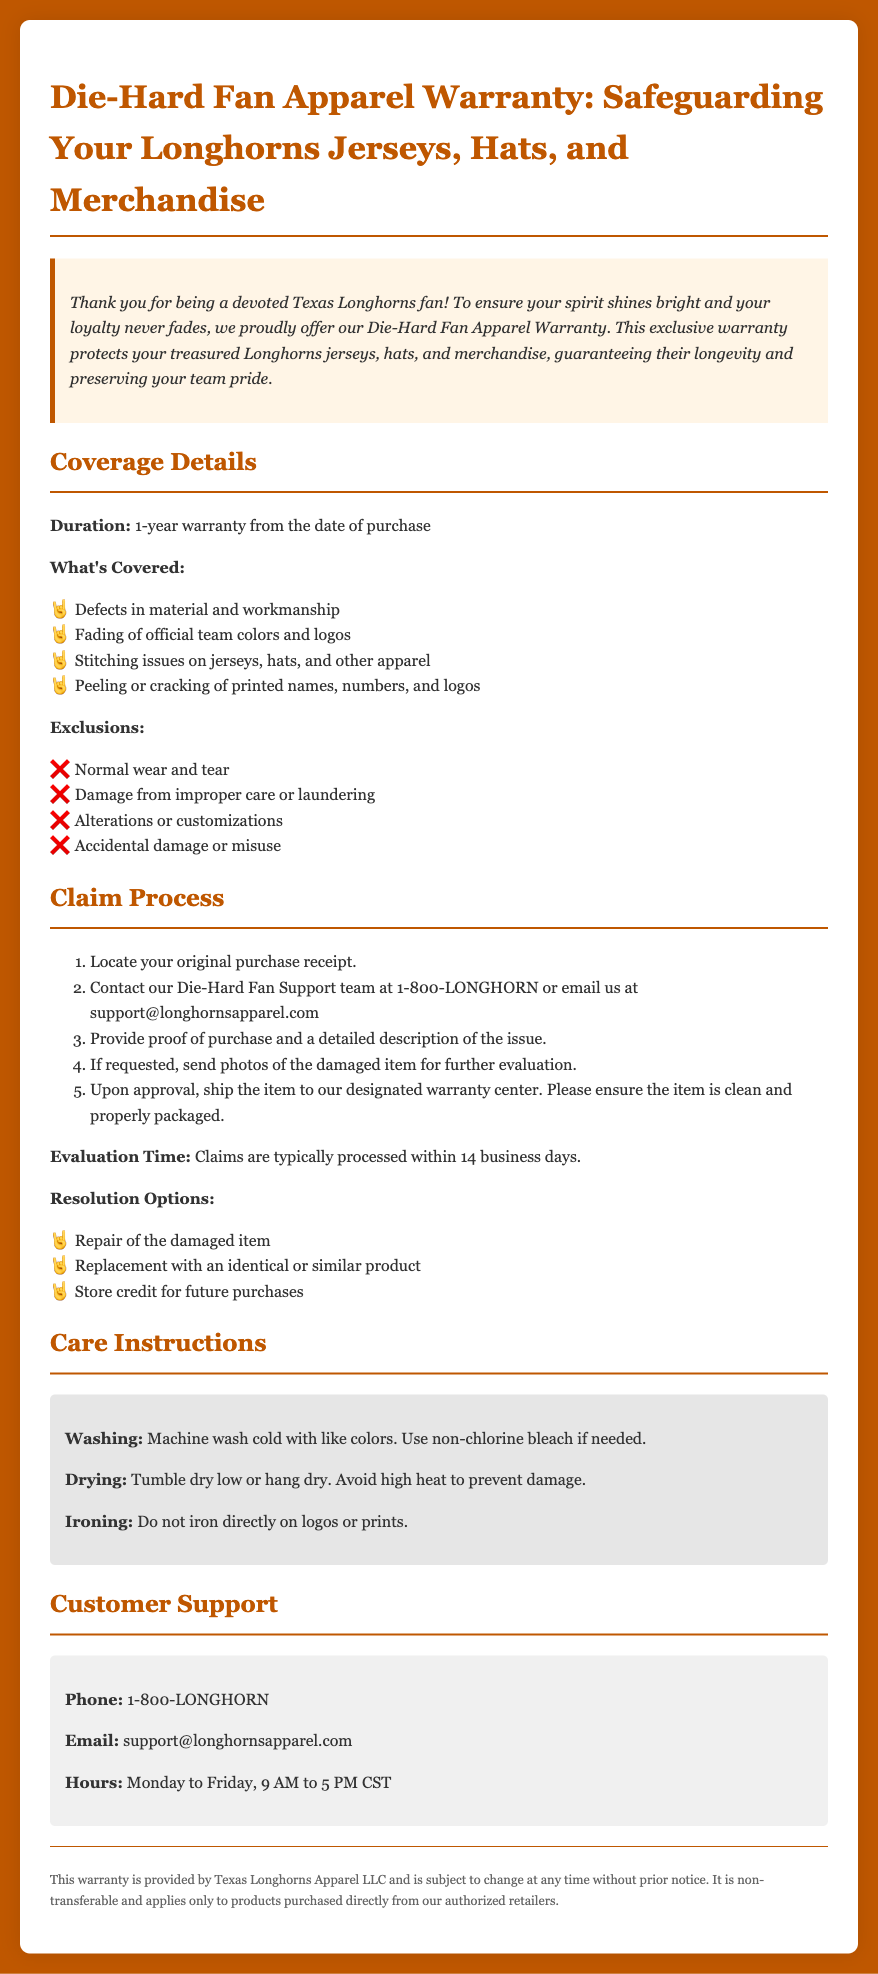What is the warranty duration? The warranty lasts for 1-year from the date of purchase according to the document.
Answer: 1-year What is covered under the warranty? The warranty covers defects in material and workmanship, among other things as listed.
Answer: Defects in material and workmanship What should you avoid to ensure coverage? The exclusions list what should be avoided; for instance, normal wear and tear is one of the exclusions.
Answer: Normal wear and tear What is the customer support phone number? The document lists the customer support phone number as 1-800-LONGHORN.
Answer: 1-800-LONGHORN What documentation is needed to file a claim? You need to provide the original purchase receipt to file a claim, as mentioned in the claim process.
Answer: Original purchase receipt How quickly are claims processed? The document states that claims are typically processed within 14 business days.
Answer: 14 business days What options are available for resolution? The warranty provides multiple resolution options, including repair or replacement of the item.
Answer: Repair of the damaged item What is the care instruction for washing? The document specifically instructs to machine wash cold with like colors.
Answer: Machine wash cold with like colors What are the warranty exclusions? Exclusions include damage from improper care or laundering, among others.
Answer: Damage from improper care or laundering 